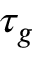Convert formula to latex. <formula><loc_0><loc_0><loc_500><loc_500>\tau _ { g }</formula> 